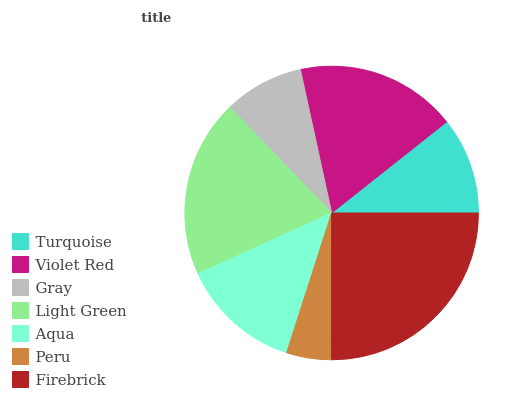Is Peru the minimum?
Answer yes or no. Yes. Is Firebrick the maximum?
Answer yes or no. Yes. Is Violet Red the minimum?
Answer yes or no. No. Is Violet Red the maximum?
Answer yes or no. No. Is Violet Red greater than Turquoise?
Answer yes or no. Yes. Is Turquoise less than Violet Red?
Answer yes or no. Yes. Is Turquoise greater than Violet Red?
Answer yes or no. No. Is Violet Red less than Turquoise?
Answer yes or no. No. Is Aqua the high median?
Answer yes or no. Yes. Is Aqua the low median?
Answer yes or no. Yes. Is Turquoise the high median?
Answer yes or no. No. Is Firebrick the low median?
Answer yes or no. No. 